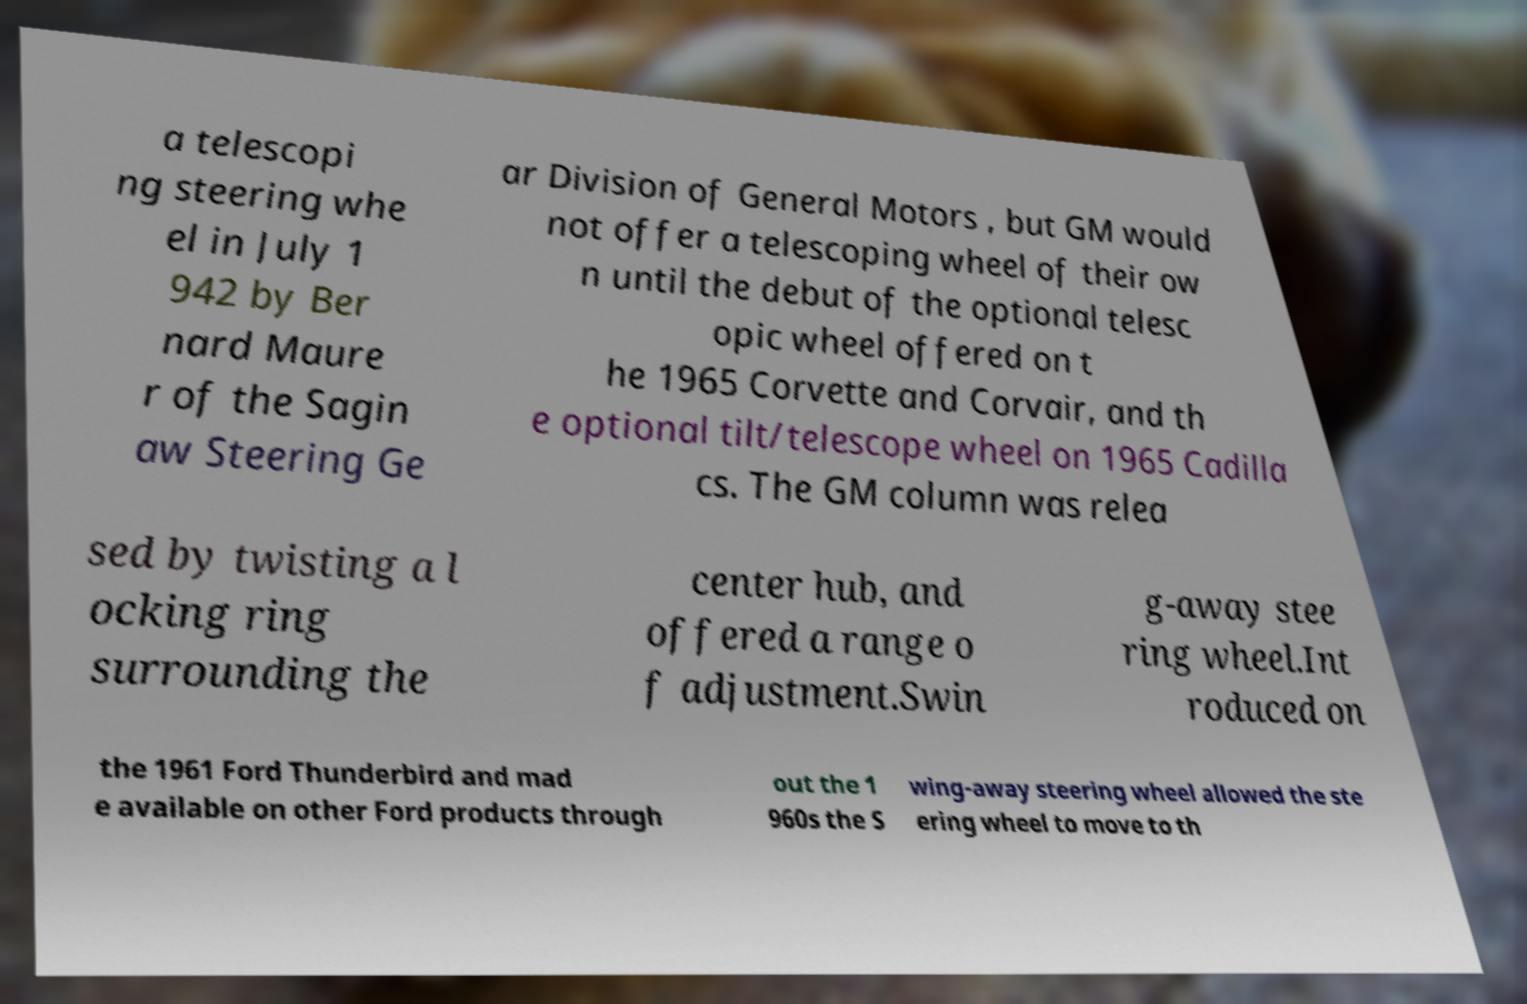For documentation purposes, I need the text within this image transcribed. Could you provide that? a telescopi ng steering whe el in July 1 942 by Ber nard Maure r of the Sagin aw Steering Ge ar Division of General Motors , but GM would not offer a telescoping wheel of their ow n until the debut of the optional telesc opic wheel offered on t he 1965 Corvette and Corvair, and th e optional tilt/telescope wheel on 1965 Cadilla cs. The GM column was relea sed by twisting a l ocking ring surrounding the center hub, and offered a range o f adjustment.Swin g-away stee ring wheel.Int roduced on the 1961 Ford Thunderbird and mad e available on other Ford products through out the 1 960s the S wing-away steering wheel allowed the ste ering wheel to move to th 